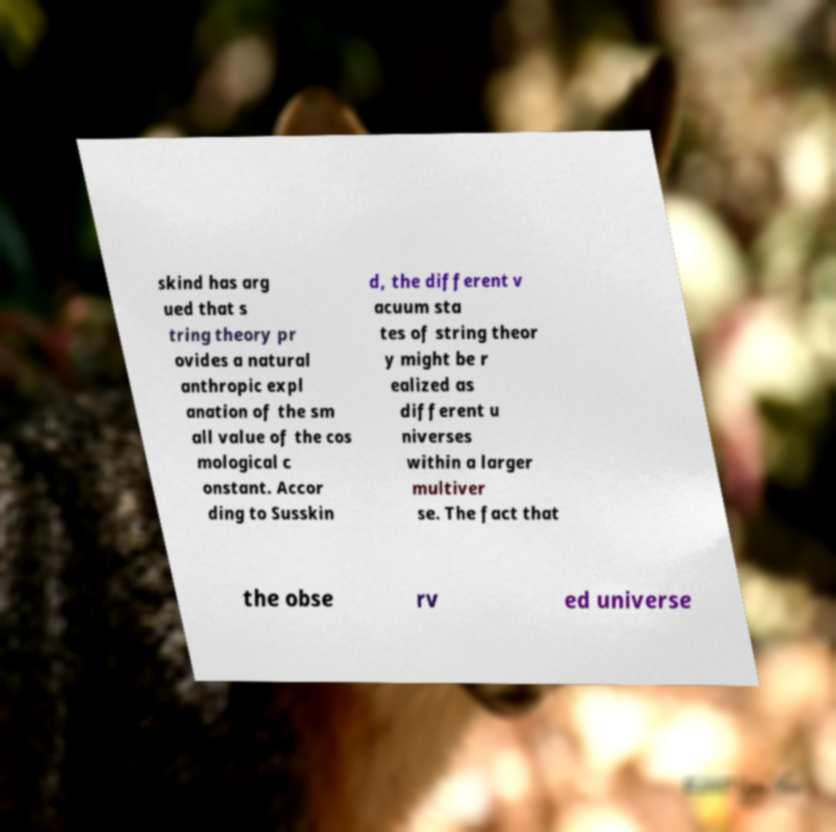Please identify and transcribe the text found in this image. skind has arg ued that s tring theory pr ovides a natural anthropic expl anation of the sm all value of the cos mological c onstant. Accor ding to Susskin d, the different v acuum sta tes of string theor y might be r ealized as different u niverses within a larger multiver se. The fact that the obse rv ed universe 